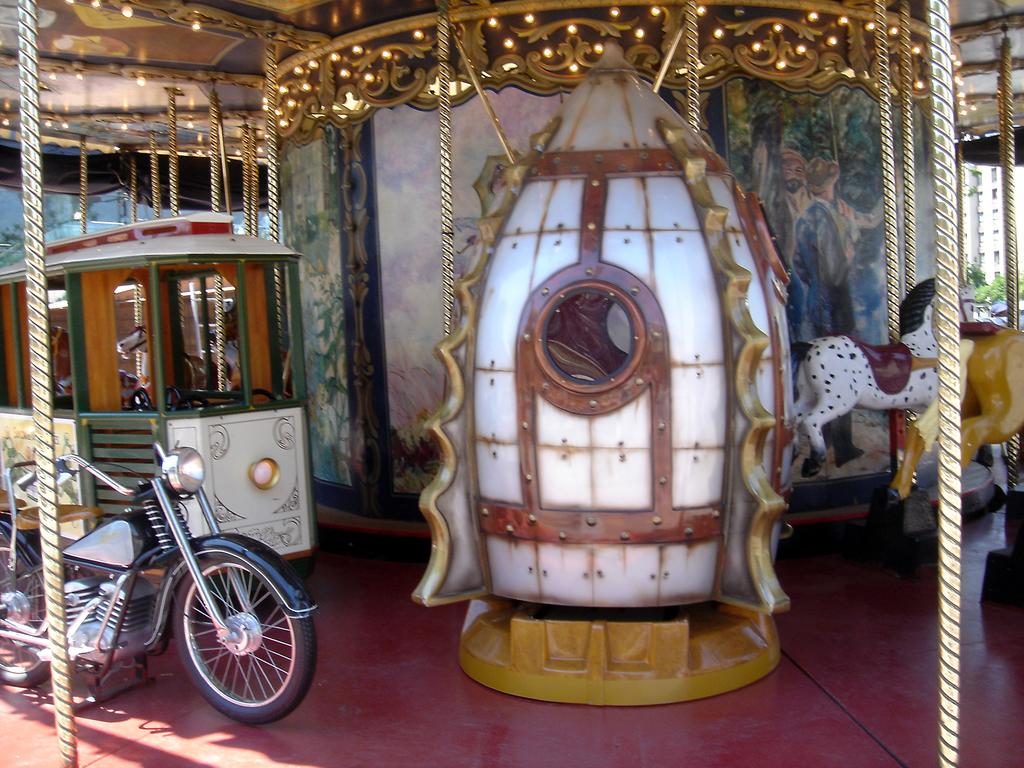What is the main subject in the image? There is a vehicle in the image. What other attraction can be seen in the image? There is an amusement ride in the image. How does the amusement ride stand out in the image? The amusement ride has a lot of decorations. How many cows are grazing on the sidewalk near the amusement ride in the image? There are no cows or sidewalks present in the image; it features a vehicle and an amusement ride with decorations. 